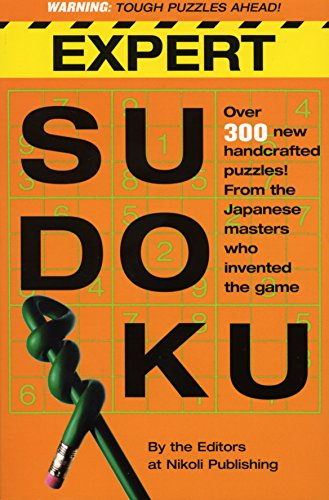Is this book related to Religion & Spirituality? No, 'Expert Sudoku' does not pertain to Religion & Spirituality. It is solely focused on Sudoku puzzles, which are part of the 'Games & Puzzles' genre. 